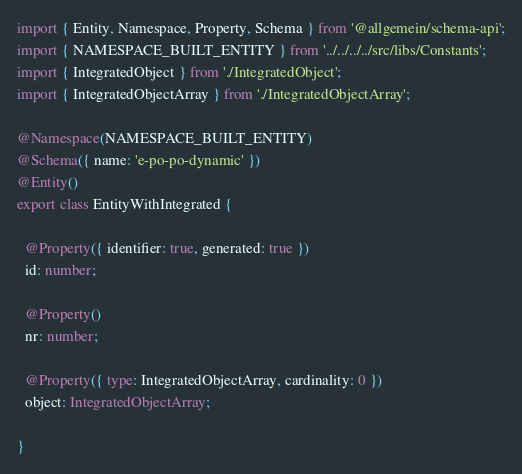<code> <loc_0><loc_0><loc_500><loc_500><_TypeScript_>import { Entity, Namespace, Property, Schema } from '@allgemein/schema-api';
import { NAMESPACE_BUILT_ENTITY } from '../../../../src/libs/Constants';
import { IntegratedObject } from './IntegratedObject';
import { IntegratedObjectArray } from './IntegratedObjectArray';

@Namespace(NAMESPACE_BUILT_ENTITY)
@Schema({ name: 'e-po-po-dynamic' })
@Entity()
export class EntityWithIntegrated {

  @Property({ identifier: true, generated: true })
  id: number;

  @Property()
  nr: number;

  @Property({ type: IntegratedObjectArray, cardinality: 0 })
  object: IntegratedObjectArray;

}
</code> 